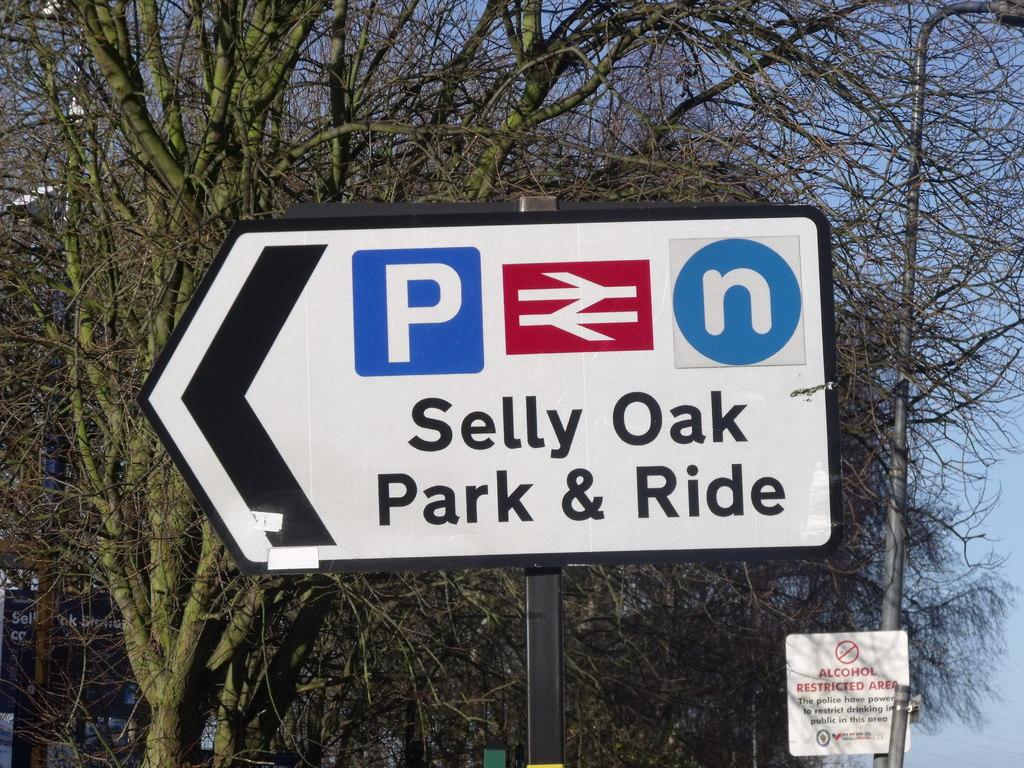Where can you park & ride at?
Make the answer very short. Selly oak. 